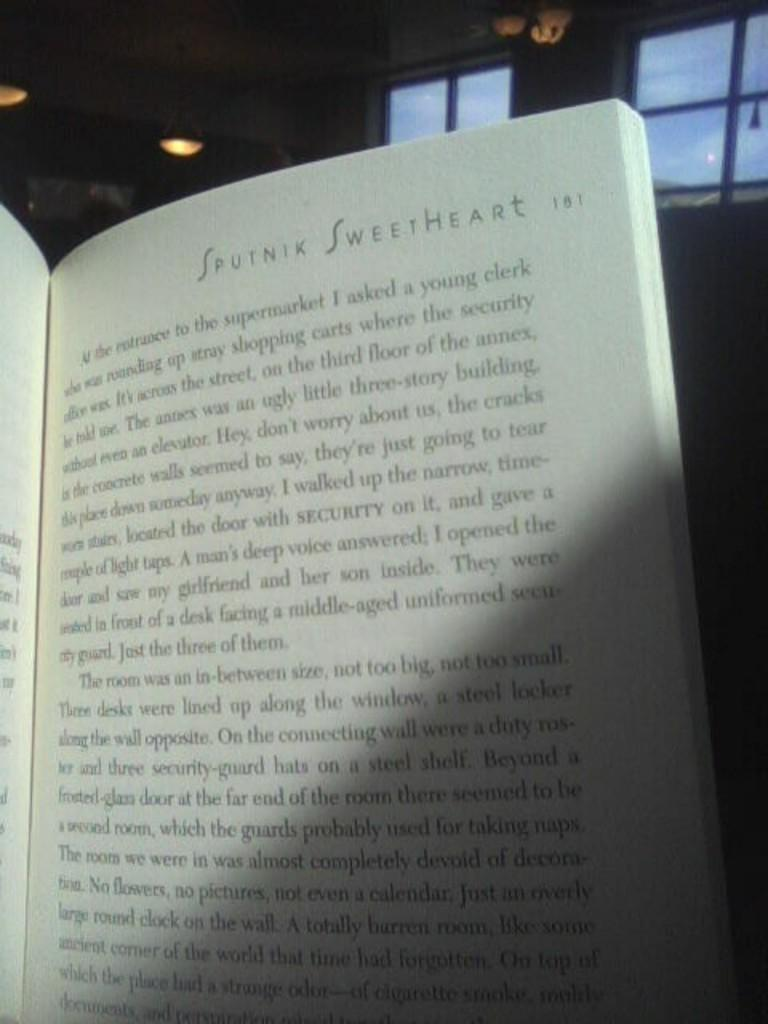Provide a one-sentence caption for the provided image. A book open to the page of Sputnik Sweetheart. 